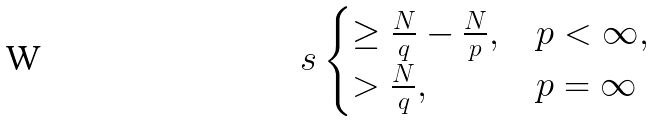Convert formula to latex. <formula><loc_0><loc_0><loc_500><loc_500>s \begin{cases} \geq \frac { N } { q } - \frac { N } { p } , & p < \infty , \\ > \frac { N } { q } , & p = \infty \end{cases}</formula> 